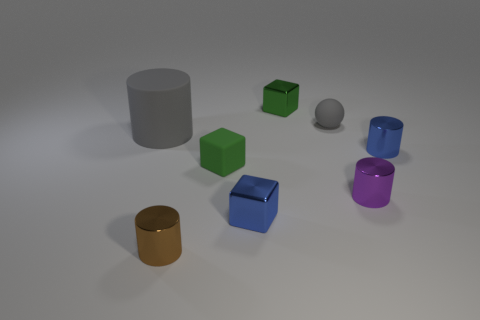Subtract all purple spheres. Subtract all cyan cylinders. How many spheres are left? 1 Add 1 big green blocks. How many objects exist? 9 Subtract all spheres. How many objects are left? 7 Subtract all big yellow spheres. Subtract all green rubber cubes. How many objects are left? 7 Add 7 small matte blocks. How many small matte blocks are left? 8 Add 2 tiny cyan things. How many tiny cyan things exist? 2 Subtract 1 gray spheres. How many objects are left? 7 